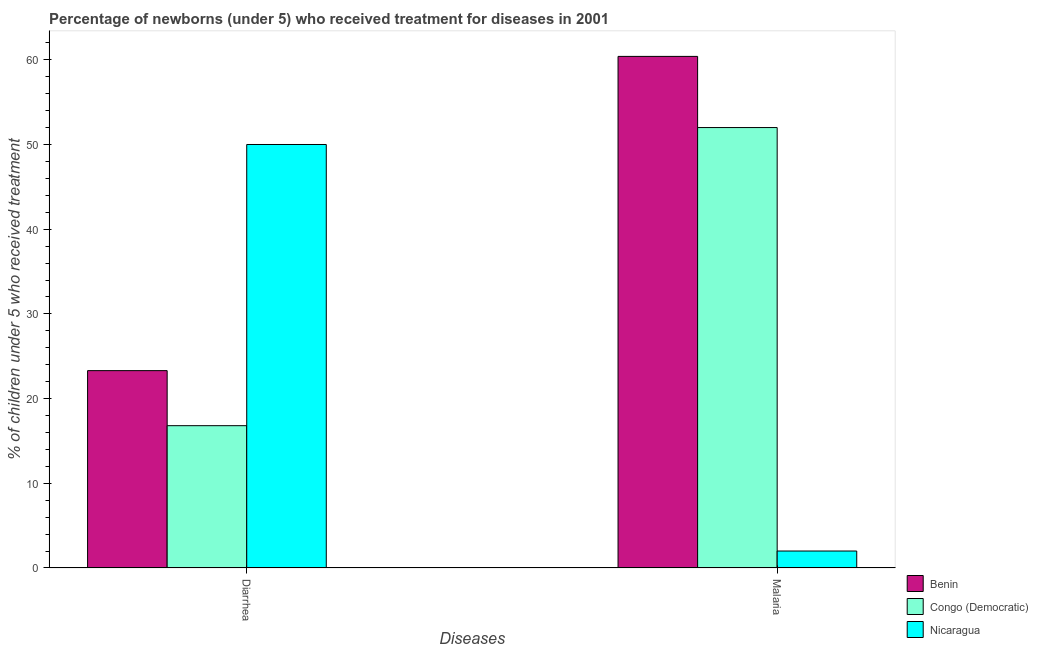How many different coloured bars are there?
Offer a very short reply. 3. Are the number of bars on each tick of the X-axis equal?
Ensure brevity in your answer.  Yes. How many bars are there on the 1st tick from the left?
Offer a terse response. 3. How many bars are there on the 2nd tick from the right?
Provide a succinct answer. 3. What is the label of the 2nd group of bars from the left?
Ensure brevity in your answer.  Malaria. What is the percentage of children who received treatment for malaria in Benin?
Ensure brevity in your answer.  60.4. Across all countries, what is the minimum percentage of children who received treatment for diarrhoea?
Provide a short and direct response. 16.8. In which country was the percentage of children who received treatment for diarrhoea maximum?
Keep it short and to the point. Nicaragua. In which country was the percentage of children who received treatment for malaria minimum?
Ensure brevity in your answer.  Nicaragua. What is the total percentage of children who received treatment for malaria in the graph?
Provide a short and direct response. 114.4. What is the difference between the percentage of children who received treatment for malaria in Benin and that in Congo (Democratic)?
Your answer should be compact. 8.4. What is the average percentage of children who received treatment for diarrhoea per country?
Your response must be concise. 30.03. What is the difference between the percentage of children who received treatment for malaria and percentage of children who received treatment for diarrhoea in Nicaragua?
Keep it short and to the point. -48. In how many countries, is the percentage of children who received treatment for malaria greater than 8 %?
Your answer should be very brief. 2. What is the ratio of the percentage of children who received treatment for malaria in Nicaragua to that in Benin?
Offer a very short reply. 0.03. In how many countries, is the percentage of children who received treatment for diarrhoea greater than the average percentage of children who received treatment for diarrhoea taken over all countries?
Provide a short and direct response. 1. What does the 1st bar from the left in Malaria represents?
Offer a terse response. Benin. What does the 3rd bar from the right in Malaria represents?
Make the answer very short. Benin. Are the values on the major ticks of Y-axis written in scientific E-notation?
Ensure brevity in your answer.  No. Does the graph contain any zero values?
Keep it short and to the point. No. How many legend labels are there?
Your response must be concise. 3. How are the legend labels stacked?
Your response must be concise. Vertical. What is the title of the graph?
Make the answer very short. Percentage of newborns (under 5) who received treatment for diseases in 2001. What is the label or title of the X-axis?
Your answer should be compact. Diseases. What is the label or title of the Y-axis?
Give a very brief answer. % of children under 5 who received treatment. What is the % of children under 5 who received treatment of Benin in Diarrhea?
Your response must be concise. 23.3. What is the % of children under 5 who received treatment of Benin in Malaria?
Make the answer very short. 60.4. What is the % of children under 5 who received treatment in Congo (Democratic) in Malaria?
Your response must be concise. 52. Across all Diseases, what is the maximum % of children under 5 who received treatment of Benin?
Make the answer very short. 60.4. Across all Diseases, what is the maximum % of children under 5 who received treatment of Congo (Democratic)?
Your response must be concise. 52. Across all Diseases, what is the maximum % of children under 5 who received treatment in Nicaragua?
Give a very brief answer. 50. Across all Diseases, what is the minimum % of children under 5 who received treatment of Benin?
Offer a terse response. 23.3. Across all Diseases, what is the minimum % of children under 5 who received treatment in Nicaragua?
Offer a terse response. 2. What is the total % of children under 5 who received treatment in Benin in the graph?
Ensure brevity in your answer.  83.7. What is the total % of children under 5 who received treatment of Congo (Democratic) in the graph?
Keep it short and to the point. 68.8. What is the difference between the % of children under 5 who received treatment in Benin in Diarrhea and that in Malaria?
Offer a very short reply. -37.1. What is the difference between the % of children under 5 who received treatment of Congo (Democratic) in Diarrhea and that in Malaria?
Ensure brevity in your answer.  -35.2. What is the difference between the % of children under 5 who received treatment of Benin in Diarrhea and the % of children under 5 who received treatment of Congo (Democratic) in Malaria?
Offer a terse response. -28.7. What is the difference between the % of children under 5 who received treatment of Benin in Diarrhea and the % of children under 5 who received treatment of Nicaragua in Malaria?
Ensure brevity in your answer.  21.3. What is the average % of children under 5 who received treatment in Benin per Diseases?
Provide a short and direct response. 41.85. What is the average % of children under 5 who received treatment in Congo (Democratic) per Diseases?
Your answer should be compact. 34.4. What is the difference between the % of children under 5 who received treatment in Benin and % of children under 5 who received treatment in Congo (Democratic) in Diarrhea?
Give a very brief answer. 6.5. What is the difference between the % of children under 5 who received treatment of Benin and % of children under 5 who received treatment of Nicaragua in Diarrhea?
Ensure brevity in your answer.  -26.7. What is the difference between the % of children under 5 who received treatment in Congo (Democratic) and % of children under 5 who received treatment in Nicaragua in Diarrhea?
Ensure brevity in your answer.  -33.2. What is the difference between the % of children under 5 who received treatment in Benin and % of children under 5 who received treatment in Nicaragua in Malaria?
Offer a very short reply. 58.4. What is the ratio of the % of children under 5 who received treatment of Benin in Diarrhea to that in Malaria?
Your response must be concise. 0.39. What is the ratio of the % of children under 5 who received treatment of Congo (Democratic) in Diarrhea to that in Malaria?
Ensure brevity in your answer.  0.32. What is the ratio of the % of children under 5 who received treatment in Nicaragua in Diarrhea to that in Malaria?
Give a very brief answer. 25. What is the difference between the highest and the second highest % of children under 5 who received treatment of Benin?
Offer a terse response. 37.1. What is the difference between the highest and the second highest % of children under 5 who received treatment in Congo (Democratic)?
Keep it short and to the point. 35.2. What is the difference between the highest and the lowest % of children under 5 who received treatment of Benin?
Offer a very short reply. 37.1. What is the difference between the highest and the lowest % of children under 5 who received treatment of Congo (Democratic)?
Keep it short and to the point. 35.2. 